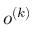Convert formula to latex. <formula><loc_0><loc_0><loc_500><loc_500>o ^ { ( k ) }</formula> 